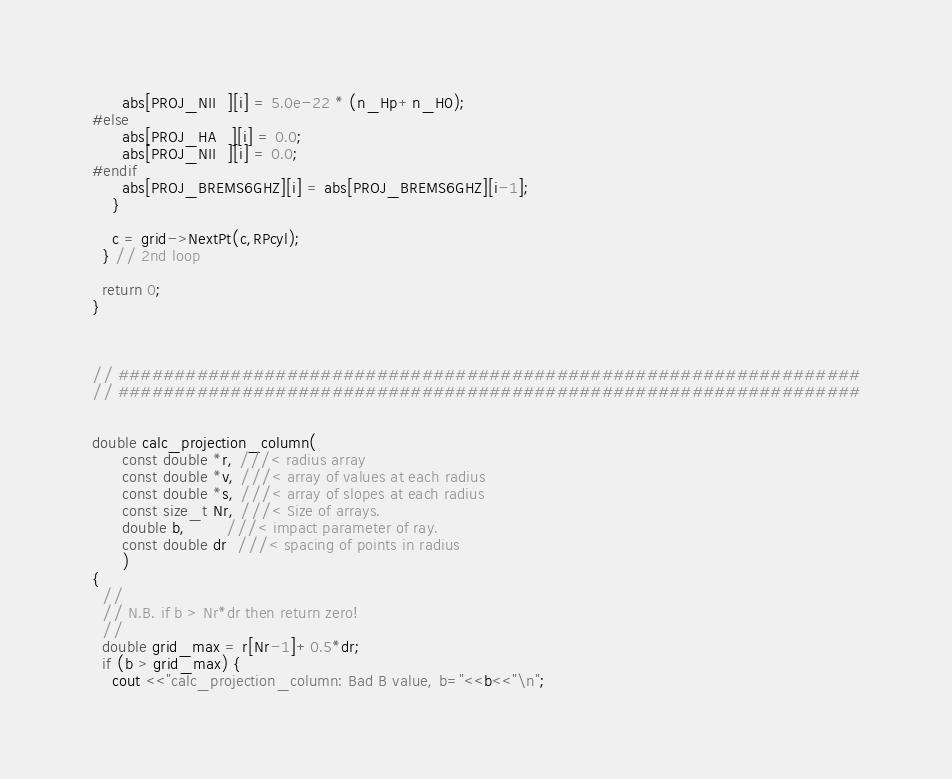Convert code to text. <code><loc_0><loc_0><loc_500><loc_500><_C++_>      abs[PROJ_NII  ][i] = 5.0e-22 * (n_Hp+n_H0);
#else
      abs[PROJ_HA   ][i] = 0.0;
      abs[PROJ_NII  ][i] = 0.0;
#endif
      abs[PROJ_BREMS6GHZ][i] = abs[PROJ_BREMS6GHZ][i-1];
    }

    c = grid->NextPt(c,RPcyl);
  } // 2nd loop

  return 0;
}



// ##################################################################
// ##################################################################


double calc_projection_column(
      const double *r, ///< radius array
      const double *v, ///< array of values at each radius
      const double *s, ///< array of slopes at each radius
      const size_t Nr, ///< Size of arrays.
      double b,        ///< impact parameter of ray.
      const double dr  ///< spacing of points in radius
      )
{
  //
  // N.B. if b > Nr*dr then return zero!
  //
  double grid_max = r[Nr-1]+0.5*dr;
  if (b > grid_max) {
    cout <<"calc_projection_column: Bad B value, b="<<b<<"\n";</code> 